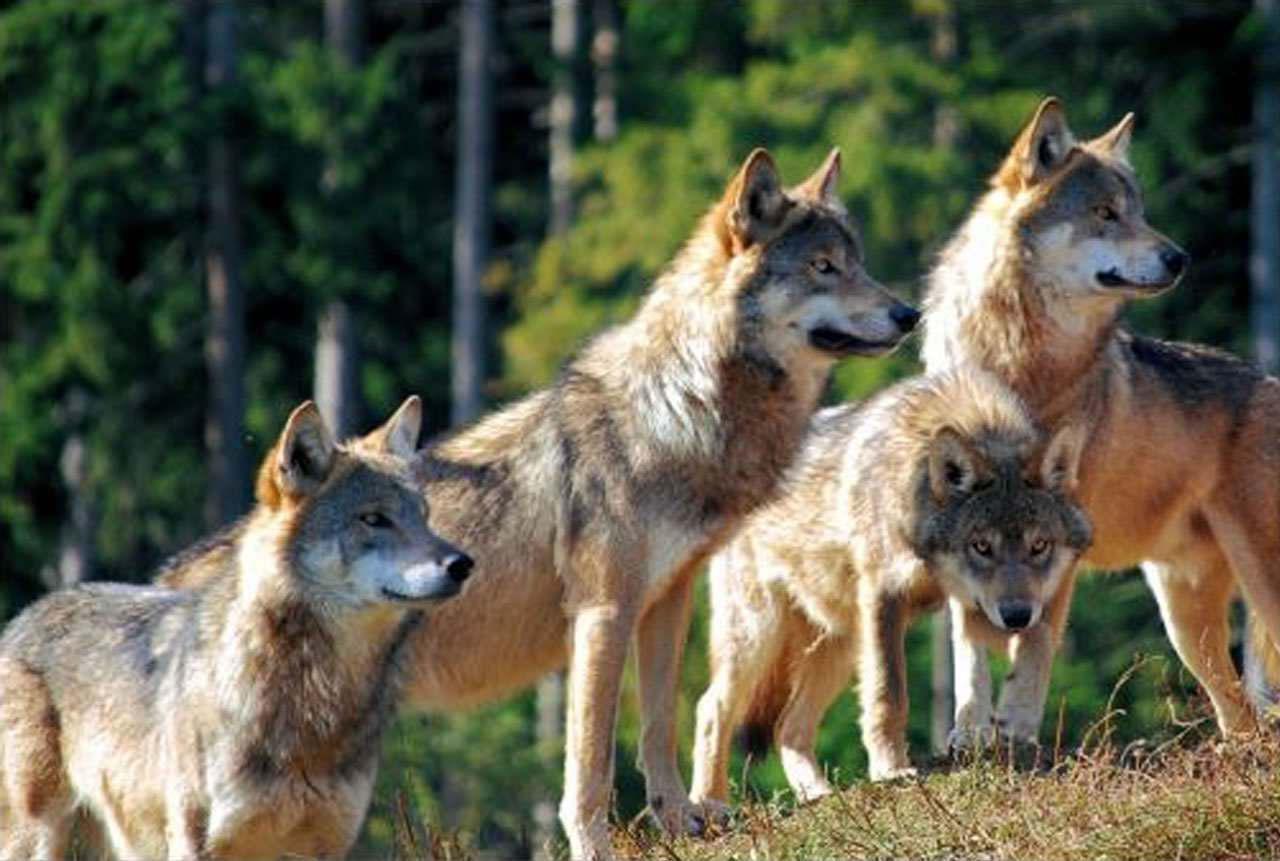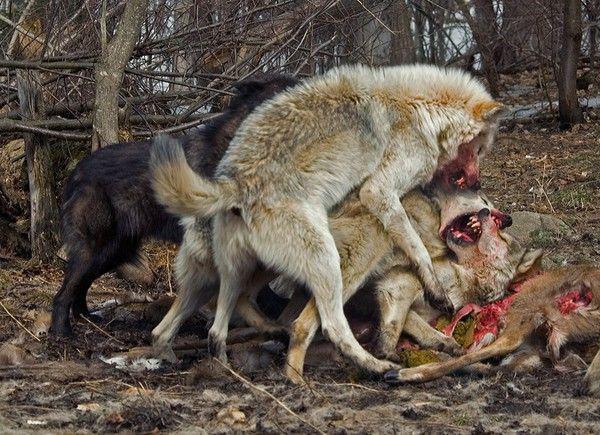The first image is the image on the left, the second image is the image on the right. Analyze the images presented: Is the assertion "There is at least one image where there are five or more wolves." valid? Answer yes or no. No. 